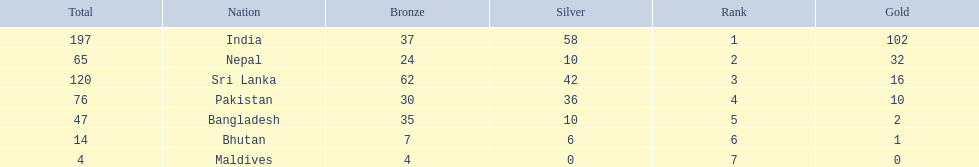What countries attended the 1999 south asian games? India, Nepal, Sri Lanka, Pakistan, Bangladesh, Bhutan, Maldives. Which of these countries had 32 gold medals? Nepal. 